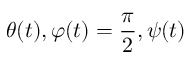Convert formula to latex. <formula><loc_0><loc_0><loc_500><loc_500>\theta ( t ) , \varphi ( t ) = \frac { \pi } { 2 } , \psi ( t )</formula> 